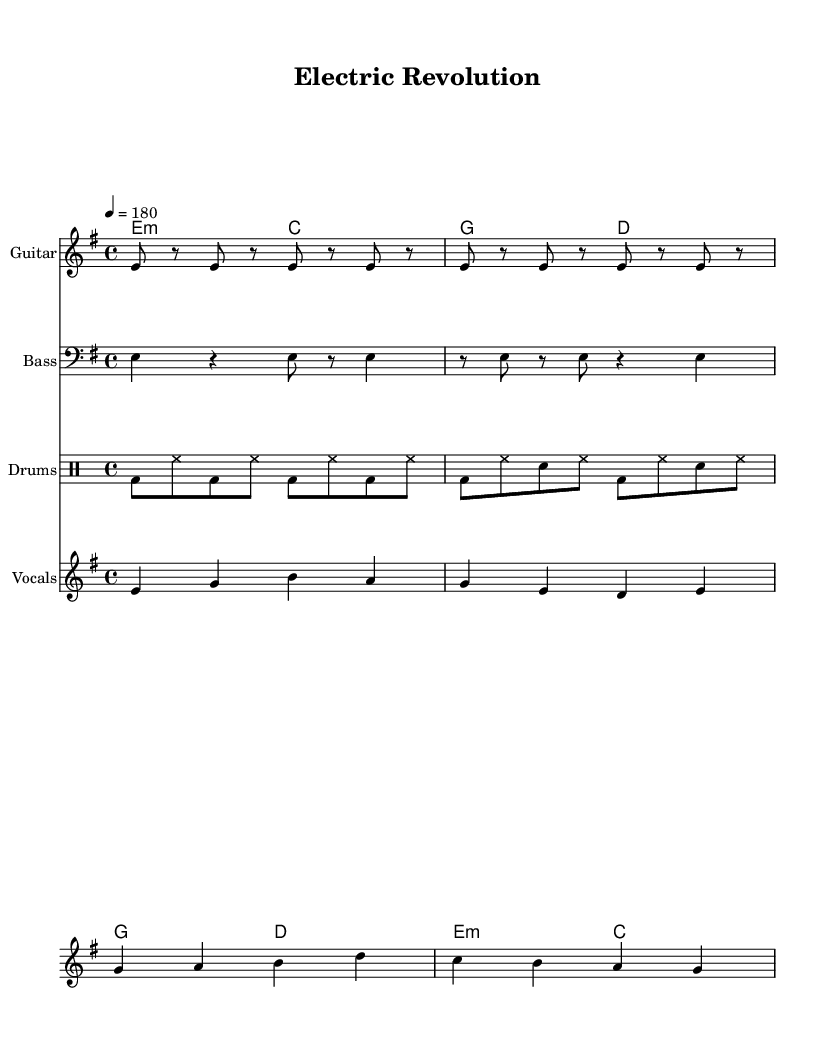What is the key signature of this music? The key signature is indicated by the arrangement of sharps or flats at the beginning of the staff. In this case, there are no accidentals shown, implying it is in E minor.
Answer: E minor What is the time signature of this music? The time signature is found at the start of the staff marked above the key signature. Here, it is represented as 4/4, indicating four beats per measure and a quarter note getting one beat.
Answer: 4/4 What is the tempo marking of the song? The tempo marking is located at the beginning of the score, and it indicates the speed of the piece. In this case, it shows a tempo of 180 beats per minute.
Answer: 180 How many measures are in the verse? To find the number of measures in the verse, we count the distinct groupings of beats in the guitar riff and the vocal melody. The verse consists of 4 measures.
Answer: 4 Which chords are used in the chorus? The chorus chords can be identified in the chord mode section for the chorus. The given chords are G major and D major, which are explicitly noted in that section.
Answer: G and D What is the main theme reflected in the lyrics? The themes can be inferred by analyzing the lyrics shown under the vocals. They express a transition from fossil fuels to electric power, advocating for clean and sustainable energy, which conveys an eco-friendly message.
Answer: Electric power and clean transportation What genre does this piece of music represent? The genre can be deduced from the fast tempo, simple structure, and lyrical content reflecting a punk attitude towards social issues. The energetic and rebellious spirit is characteristic of punk.
Answer: Punk 